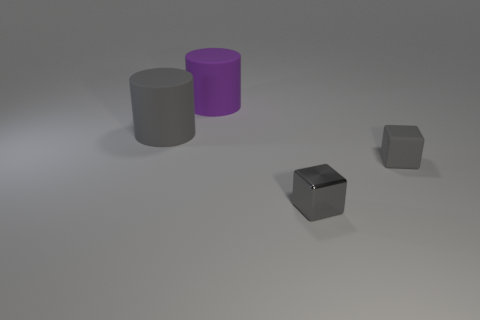Add 4 tiny gray objects. How many objects exist? 8 Add 3 big gray shiny cylinders. How many big gray shiny cylinders exist? 3 Subtract 0 red blocks. How many objects are left? 4 Subtract all large purple spheres. Subtract all purple objects. How many objects are left? 3 Add 2 tiny rubber objects. How many tiny rubber objects are left? 3 